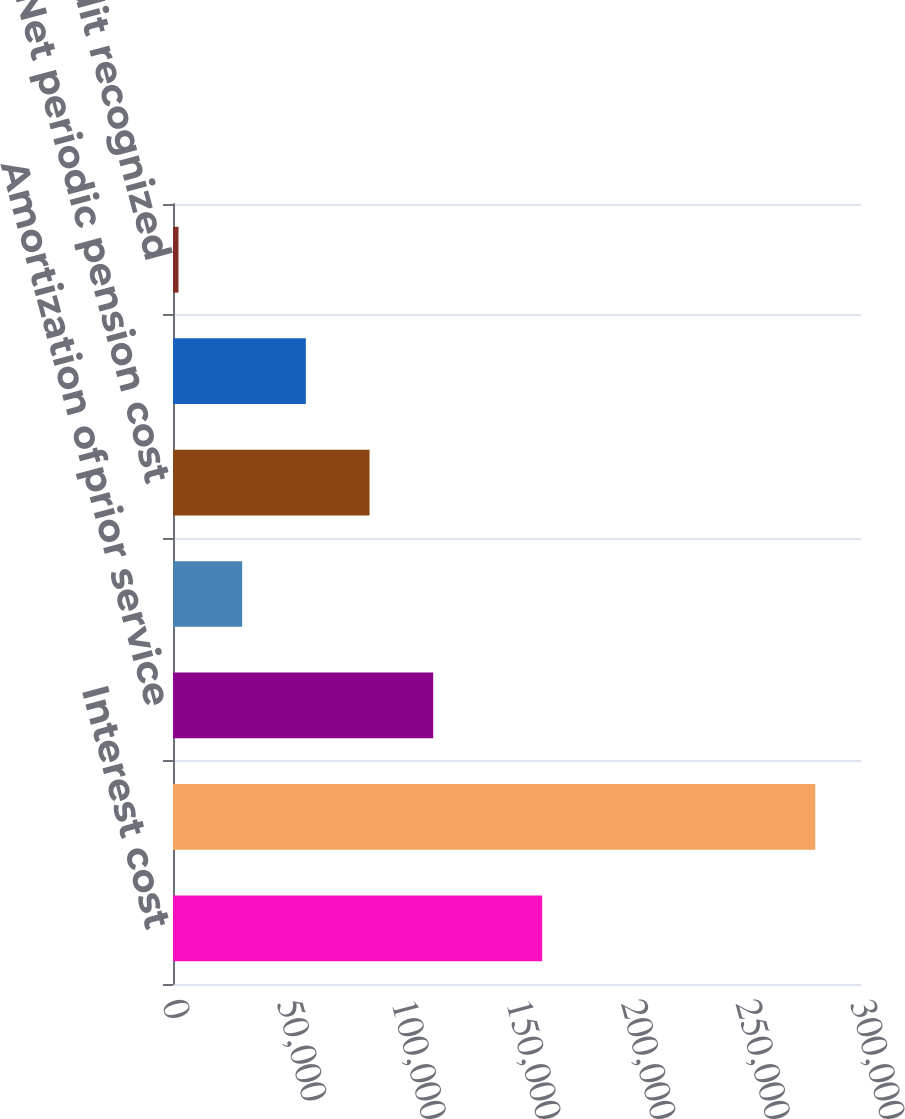Convert chart to OTSL. <chart><loc_0><loc_0><loc_500><loc_500><bar_chart><fcel>Interest cost<fcel>Expected return onplanassets<fcel>Amortization ofprior service<fcel>Amortization ofnet (gain) loss<fcel>Net periodic pension cost<fcel>Credits not recognized due<fcel>Net benefit credit recognized<nl><fcel>160985<fcel>280064<fcel>113463<fcel>30162.8<fcel>85696.4<fcel>57929.6<fcel>2396<nl></chart> 